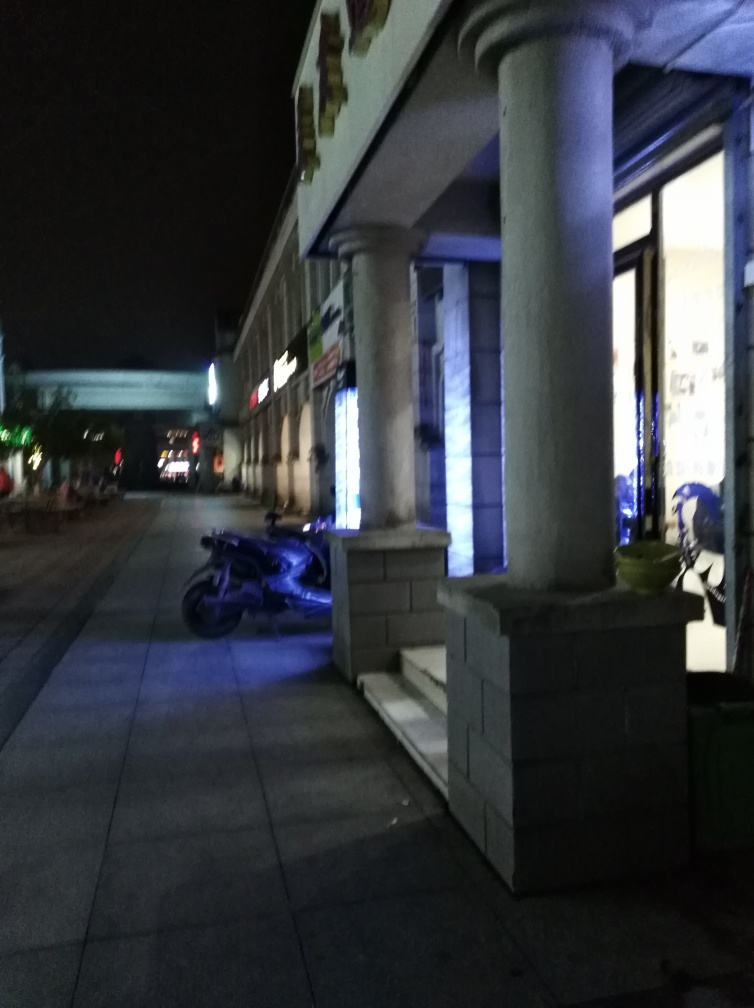What details does the ground retain? The ground in the image retains some texture details, which are evident despite the low lighting conditions. The tiles appear relatively flat but have subtle variations in color and reflectivity, which would suggest option 'A. Some texture details' is correct. 